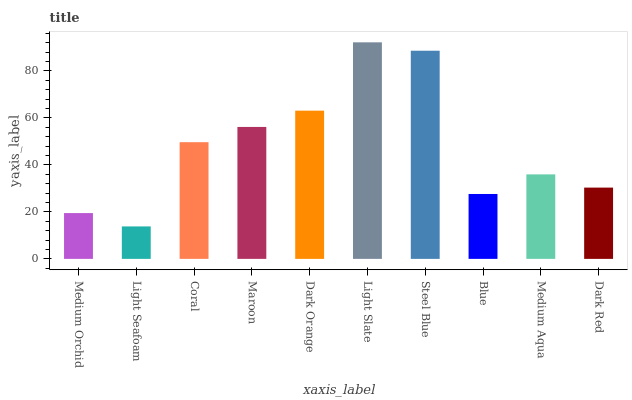Is Light Seafoam the minimum?
Answer yes or no. Yes. Is Light Slate the maximum?
Answer yes or no. Yes. Is Coral the minimum?
Answer yes or no. No. Is Coral the maximum?
Answer yes or no. No. Is Coral greater than Light Seafoam?
Answer yes or no. Yes. Is Light Seafoam less than Coral?
Answer yes or no. Yes. Is Light Seafoam greater than Coral?
Answer yes or no. No. Is Coral less than Light Seafoam?
Answer yes or no. No. Is Coral the high median?
Answer yes or no. Yes. Is Medium Aqua the low median?
Answer yes or no. Yes. Is Steel Blue the high median?
Answer yes or no. No. Is Light Slate the low median?
Answer yes or no. No. 